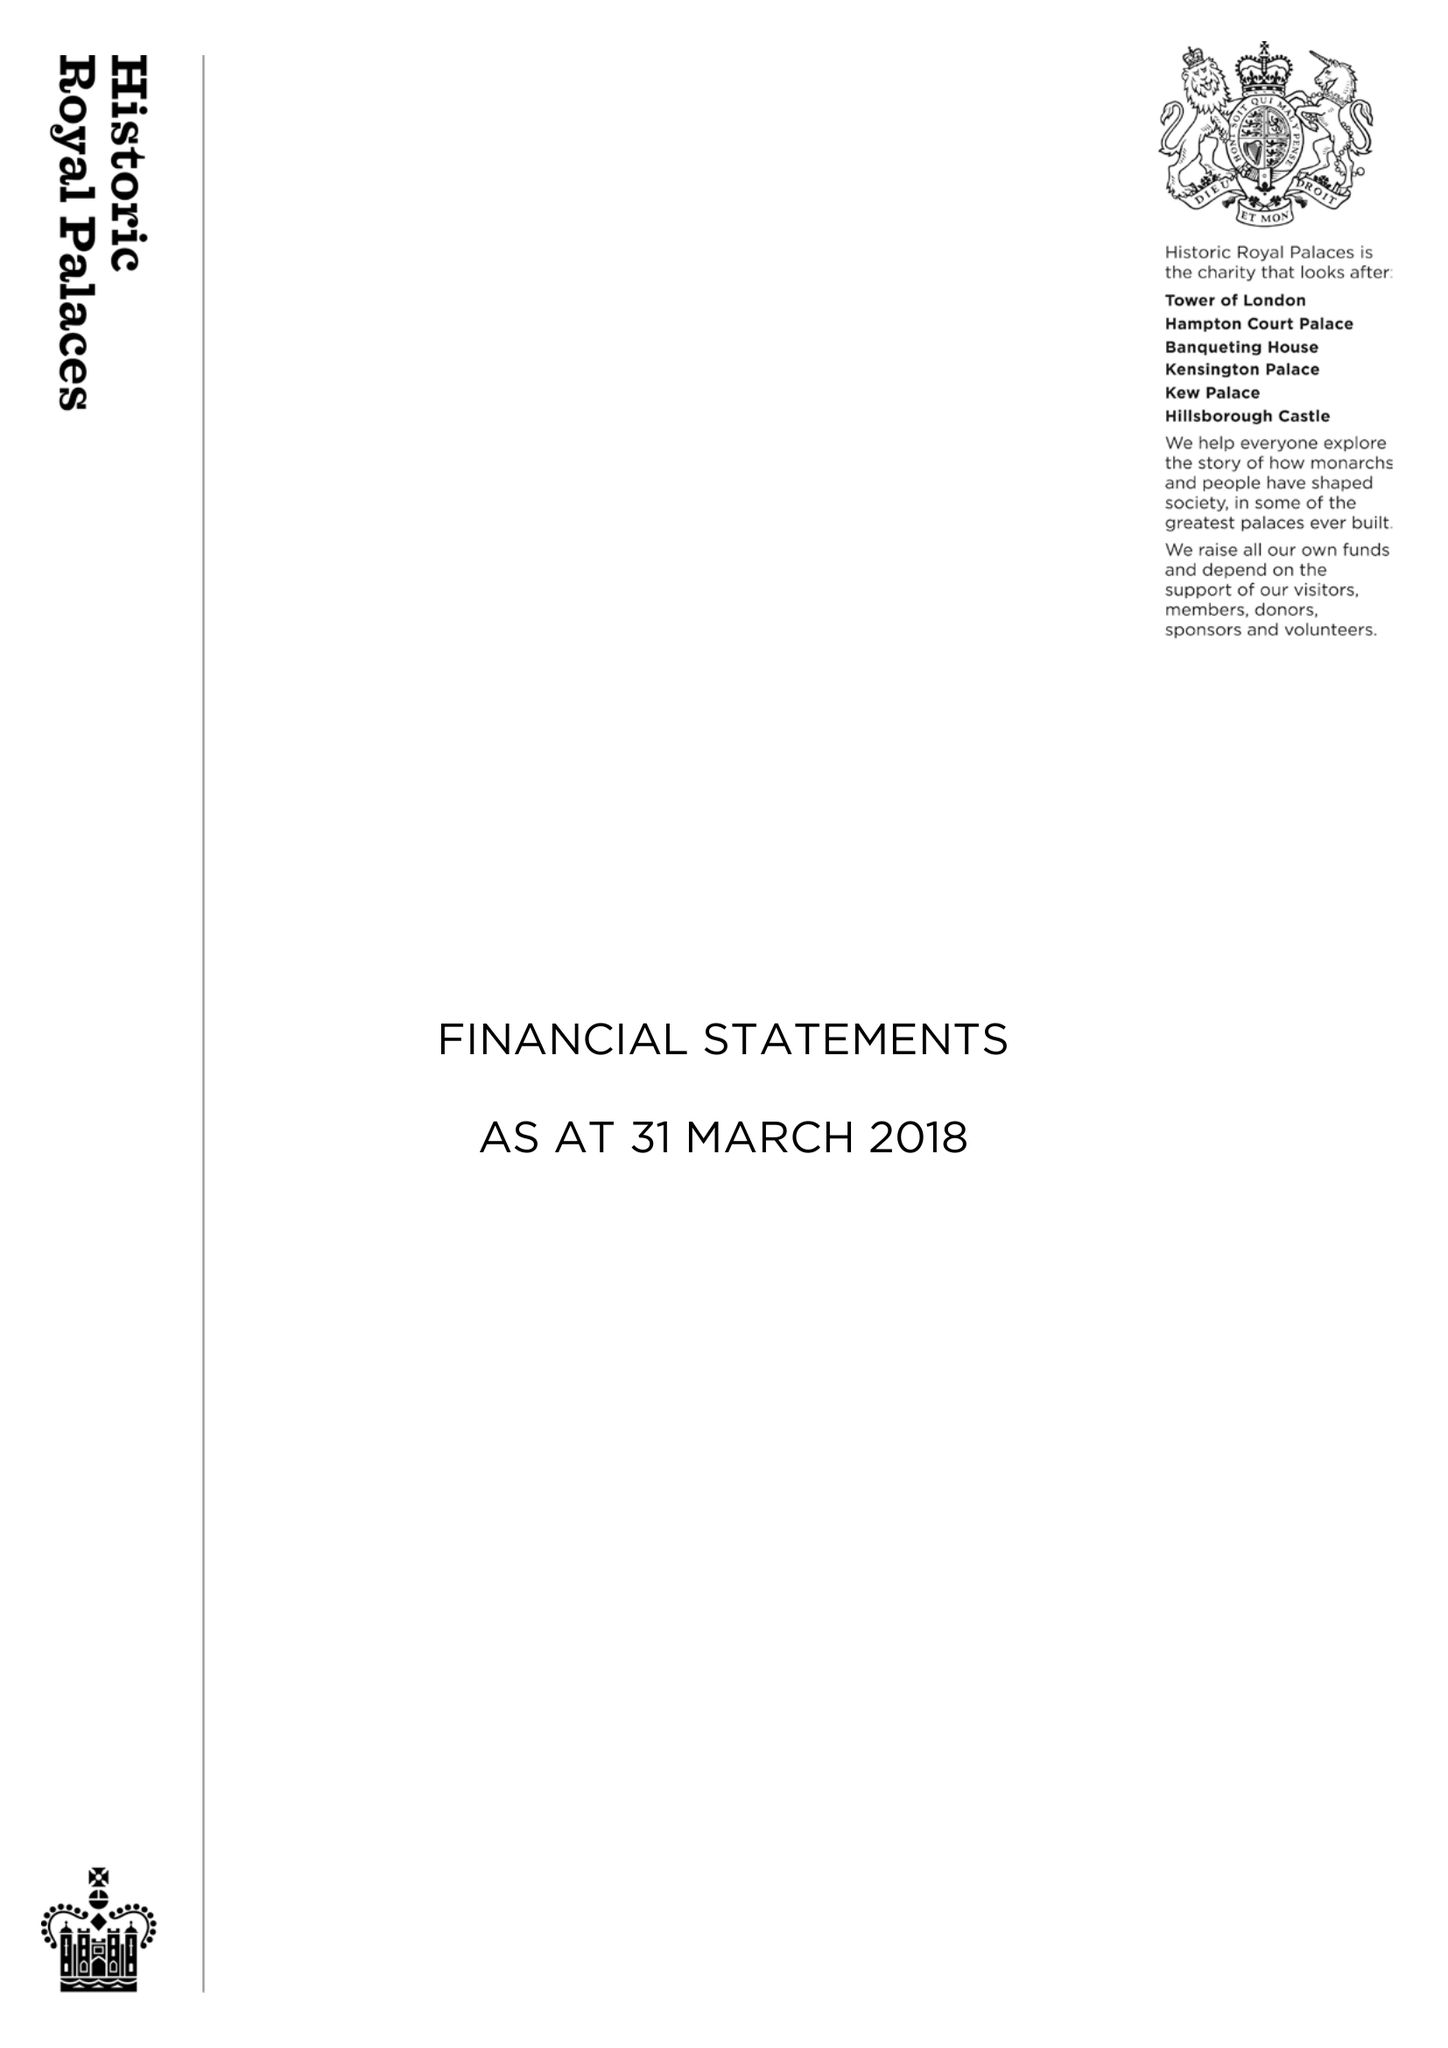What is the value for the address__post_town?
Answer the question using a single word or phrase. WEST MOLESEY 